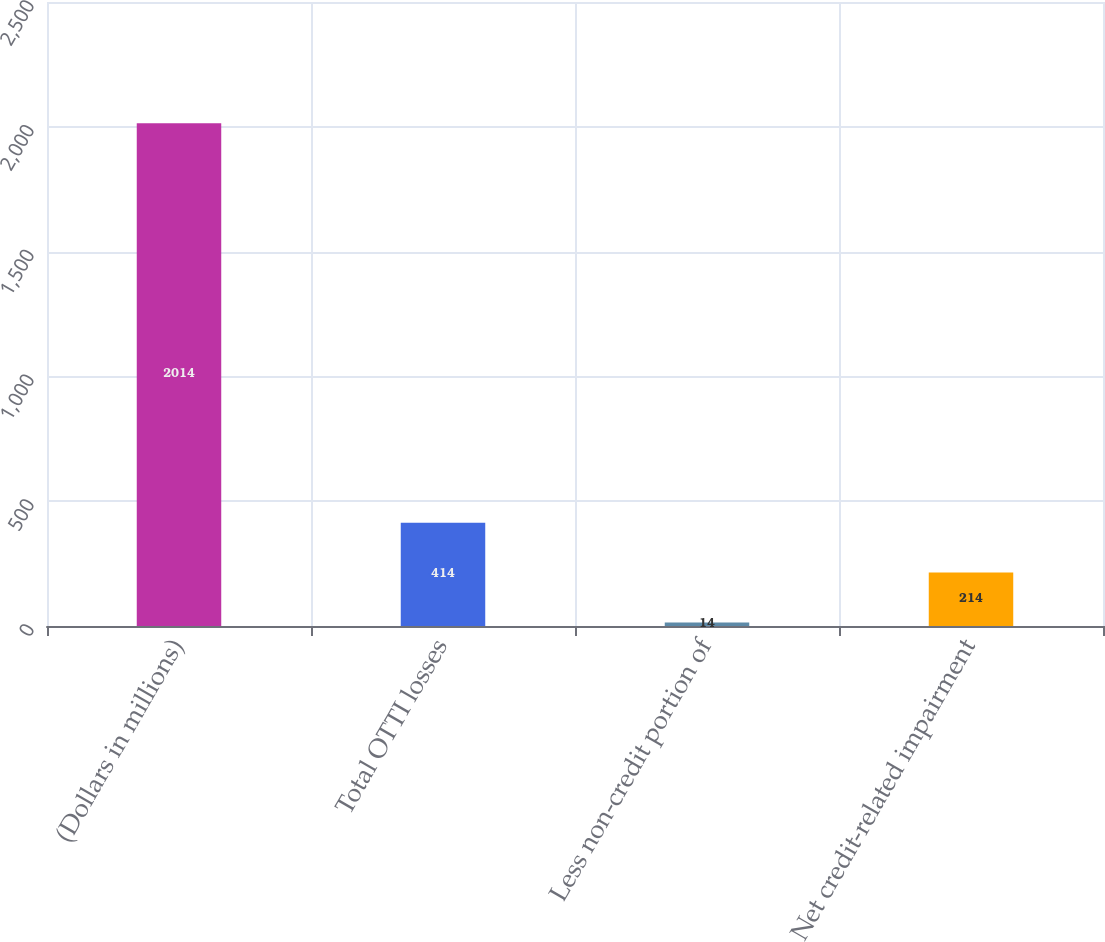Convert chart. <chart><loc_0><loc_0><loc_500><loc_500><bar_chart><fcel>(Dollars in millions)<fcel>Total OTTI losses<fcel>Less non-credit portion of<fcel>Net credit-related impairment<nl><fcel>2014<fcel>414<fcel>14<fcel>214<nl></chart> 